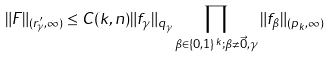Convert formula to latex. <formula><loc_0><loc_0><loc_500><loc_500>\| F \| _ { ( r _ { \gamma } ^ { \prime } , \infty ) } \leq C ( k , n ) \| f _ { \gamma } \| _ { q _ { \gamma } } \prod _ { \beta \in \{ 0 , 1 \} ^ { k } ; \beta \not = \vec { 0 } , \gamma } \| f _ { \beta } \| _ { ( p _ { k } , \infty ) }</formula> 